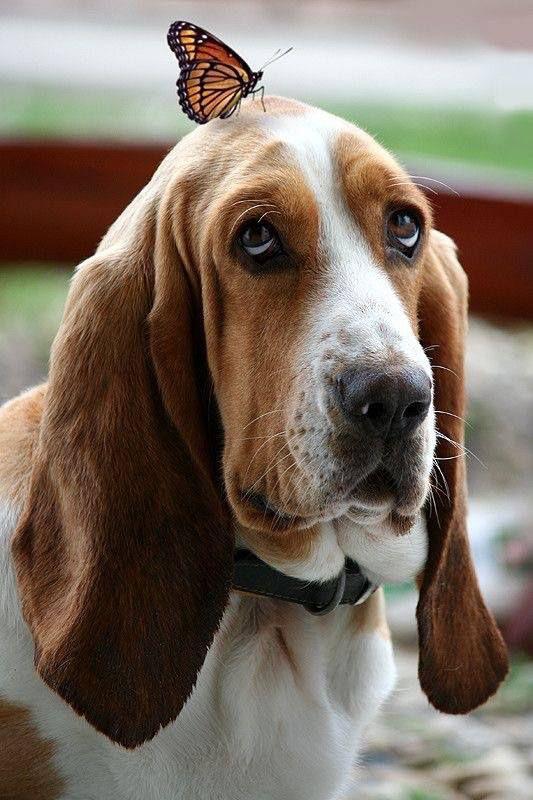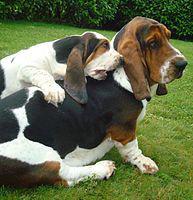The first image is the image on the left, the second image is the image on the right. Assess this claim about the two images: "At least one dog has no visible black in their fur.". Correct or not? Answer yes or no. Yes. 